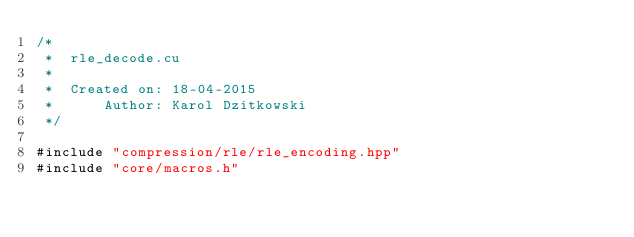Convert code to text. <code><loc_0><loc_0><loc_500><loc_500><_Cuda_>/*
 *  rle_decode.cu
 *
 *  Created on: 18-04-2015
 *      Author: Karol Dzitkowski
 */

#include "compression/rle/rle_encoding.hpp"
#include "core/macros.h"
</code> 